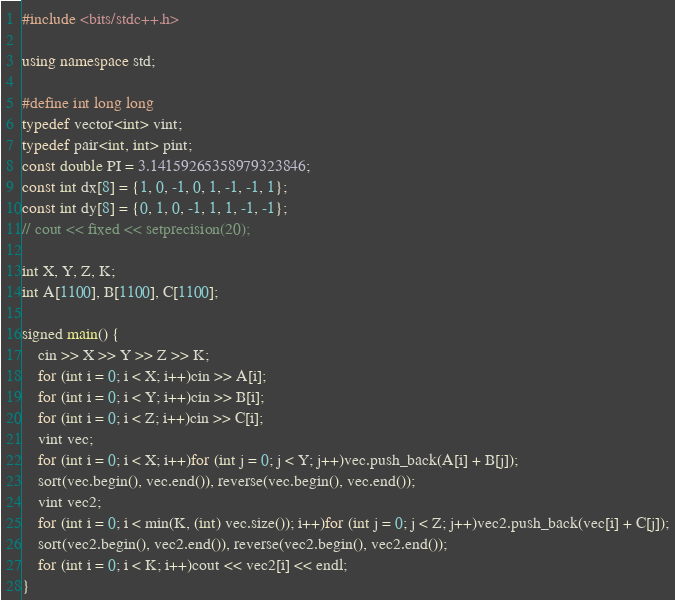Convert code to text. <code><loc_0><loc_0><loc_500><loc_500><_C++_>#include <bits/stdc++.h>

using namespace std;

#define int long long
typedef vector<int> vint;
typedef pair<int, int> pint;
const double PI = 3.14159265358979323846;
const int dx[8] = {1, 0, -1, 0, 1, -1, -1, 1};
const int dy[8] = {0, 1, 0, -1, 1, 1, -1, -1};
// cout << fixed << setprecision(20);

int X, Y, Z, K;
int A[1100], B[1100], C[1100];

signed main() {
    cin >> X >> Y >> Z >> K;
    for (int i = 0; i < X; i++)cin >> A[i];
    for (int i = 0; i < Y; i++)cin >> B[i];
    for (int i = 0; i < Z; i++)cin >> C[i];
    vint vec;
    for (int i = 0; i < X; i++)for (int j = 0; j < Y; j++)vec.push_back(A[i] + B[j]);
    sort(vec.begin(), vec.end()), reverse(vec.begin(), vec.end());
    vint vec2;
    for (int i = 0; i < min(K, (int) vec.size()); i++)for (int j = 0; j < Z; j++)vec2.push_back(vec[i] + C[j]);
    sort(vec2.begin(), vec2.end()), reverse(vec2.begin(), vec2.end());
    for (int i = 0; i < K; i++)cout << vec2[i] << endl;
}
</code> 